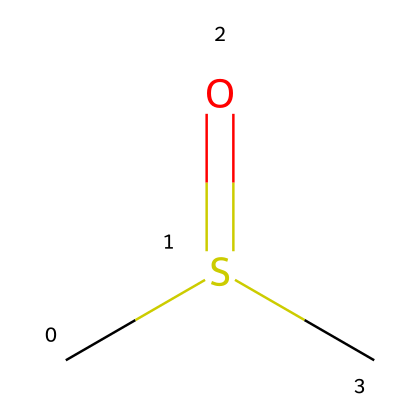What is the molecular formula of this chemical? The molecular formula can be derived from the provided SMILES representation: CS(=O)C indicates the presence of one carbon (C) atom bonded to sulfur (S) and another carbon atom. The presence of the oxygen (O) atom is indicated by the "=O" in the formula, which means one carbon atom is attached to sulfur through a double bond. Counting all atoms gives the formula C2H6OS.
Answer: C2H6OS How many total atoms are in this molecule? To determine the total number of atoms from the SMILES representation, we count each distinct atom present: 2 carbon atoms (C), 6 hydrogen atoms (H), 1 sulfur atom (S), and 1 oxygen atom (O). Adding them together gives us a total of 10 atoms.
Answer: 10 Is this chemical polar or nonpolar? The presence of the sulfur (S) and oxygen (O) atoms in the molecule introduces polarity due to their electronegativity and their differing bond characteristics with carbon. Therefore, DMSO is polar.
Answer: polar What type of solvent is dimethyl sulfoxide considered? DMSO is recognized as a polar aprotic solvent, meaning it does not have acidic protons in the molecule and can dissolve a wide range of solutes due to its polarity.
Answer: polar aprotic solvent Why is dimethyl sulfoxide commonly used in pharmaceuticals? DMSO is commonly used in pharmaceuticals due to its excellent solvent properties and ability to penetrate biological membranes, enhancing drug delivery. This is largely attributed to its polar nature and small molecular size, allowing it to interact effectively with both polar and nonpolar substances.
Answer: drug delivery Does dimethyl sulfoxide have any specific functional groups? Yes, dimethyl sulfoxide contains a sulfoxide functional group, characterized by the sulfur atom bonded to an oxygen atom with a double bond. This is identified in the SMILES as S(=O).
Answer: sulfoxide 